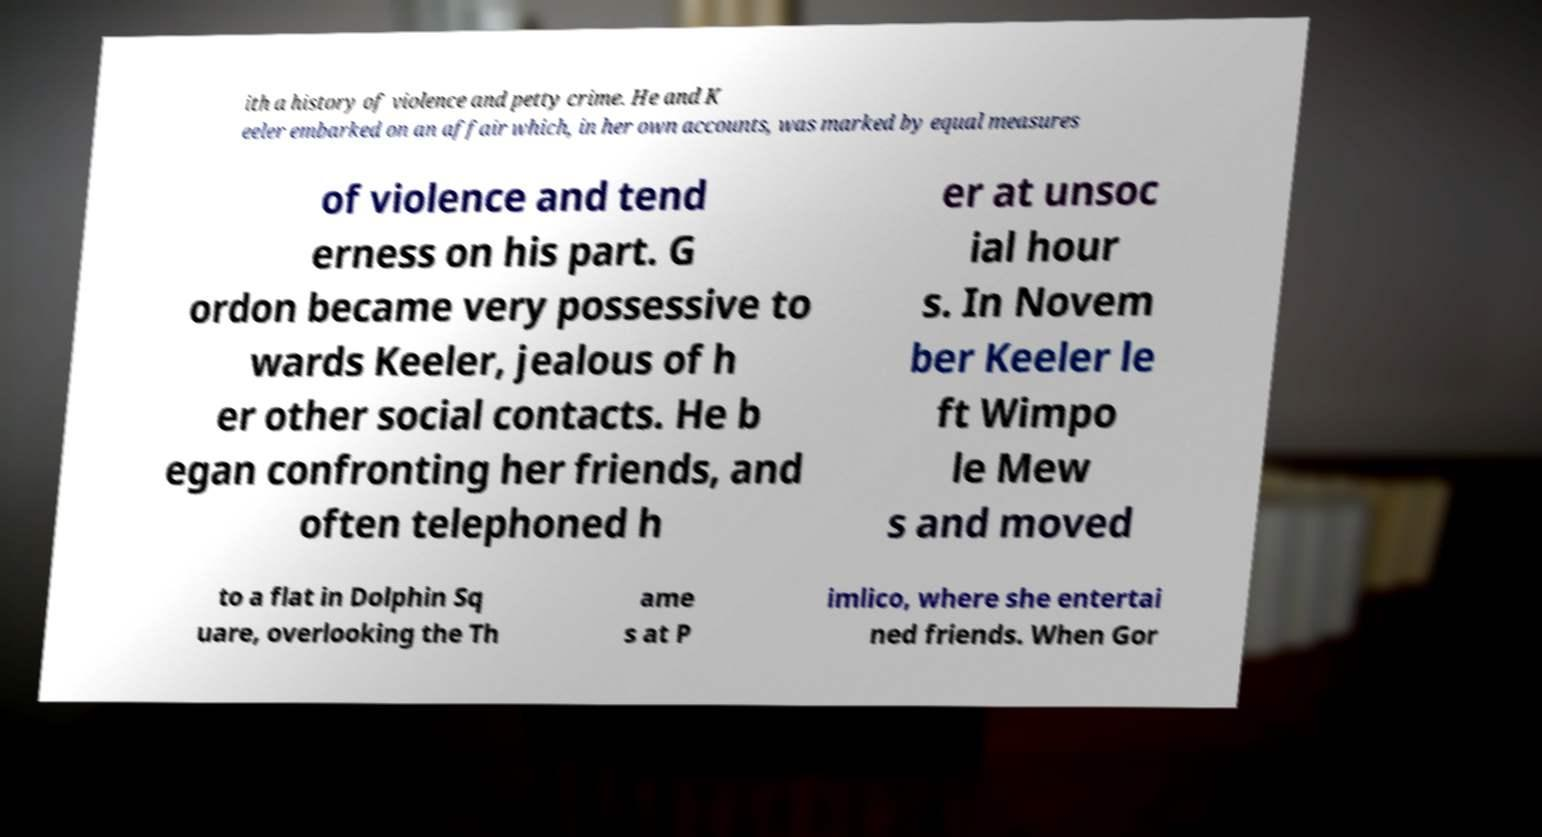Please identify and transcribe the text found in this image. ith a history of violence and petty crime. He and K eeler embarked on an affair which, in her own accounts, was marked by equal measures of violence and tend erness on his part. G ordon became very possessive to wards Keeler, jealous of h er other social contacts. He b egan confronting her friends, and often telephoned h er at unsoc ial hour s. In Novem ber Keeler le ft Wimpo le Mew s and moved to a flat in Dolphin Sq uare, overlooking the Th ame s at P imlico, where she entertai ned friends. When Gor 